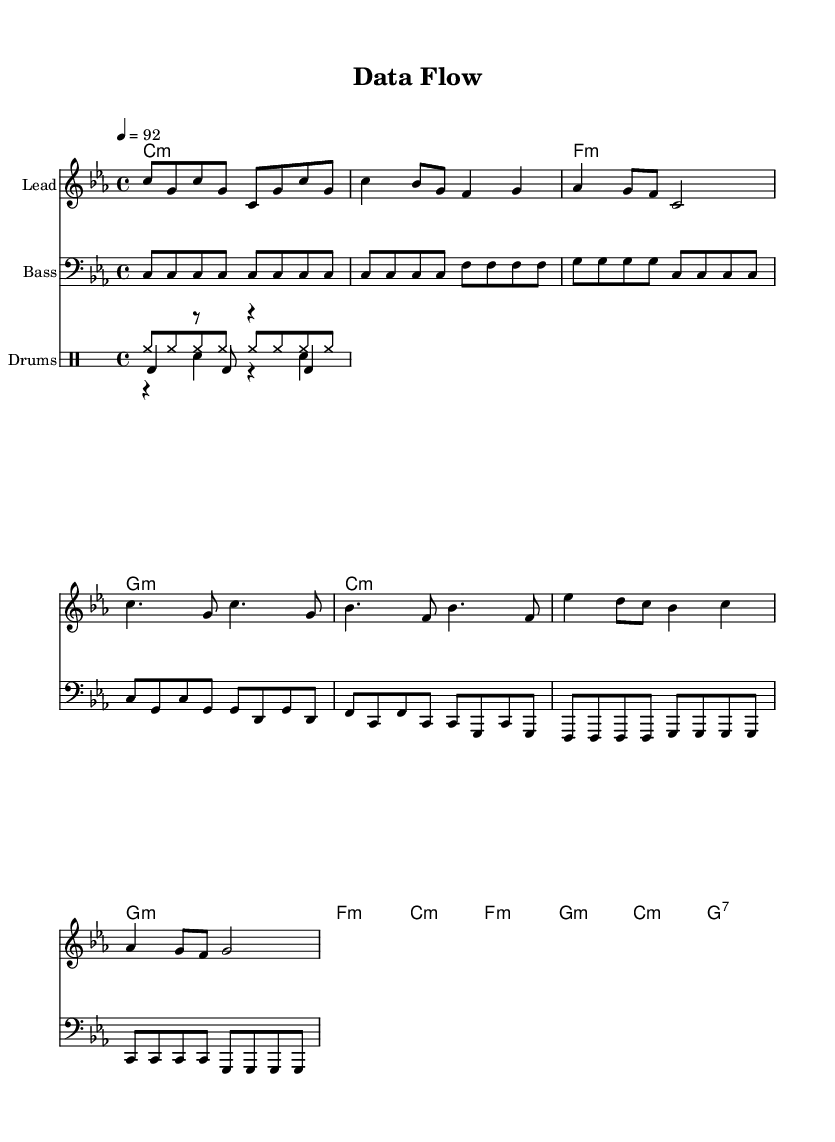What is the key signature of this music? The key signature is C minor, which is indicated by the presence of three flats (B flat, E flat, and A flat) in the key signature section of the staff.
Answer: C minor What is the time signature of this music? The time signature is 4/4, which means there are four beats in a measure, and each quarter note gets one beat. This is indicated at the beginning of the score.
Answer: 4/4 What is the tempo marking of this music? The tempo is marked as 92 beats per minute, indicated by the tempo marking found right at the beginning of the score.
Answer: 92 How many measures are there in the chorus section? The chorus consists of four measures, identifiable by counting the measures indicated after the verse sections in the music.
Answer: 4 What instrument is indicated for the lead melody? The lead melody is specifically designated for a "Lead" instrument, which refers to the main vocal or instrumental line in the arrangement.
Answer: Lead What rhythmic pattern is predominantly used in the drum section? The drum section primarily features hi-hat patterns played in eighth notes, with alternating kick and snare hits, indicative of typical hip hop rhythms.
Answer: Hi-hat Are there any syncopations present in the melody? Yes, the melody contains syncopated rhythms, notably where the off-beats emphasize certain notes, creating a sense of movement and groove typical in hip hop music.
Answer: Yes 